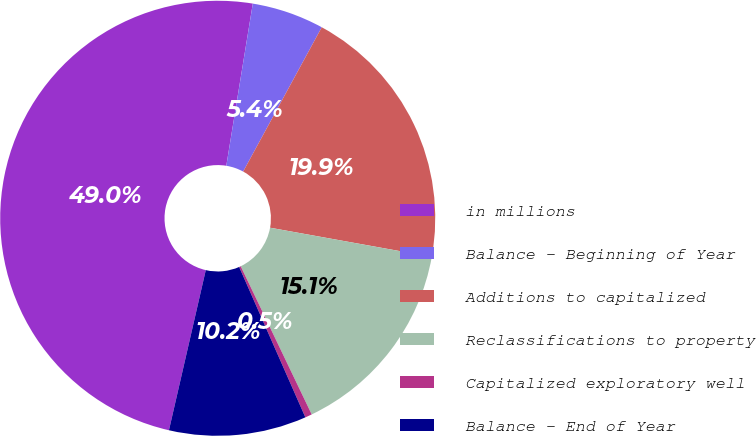Convert chart. <chart><loc_0><loc_0><loc_500><loc_500><pie_chart><fcel>in millions<fcel>Balance - Beginning of Year<fcel>Additions to capitalized<fcel>Reclassifications to property<fcel>Capitalized exploratory well<fcel>Balance - End of Year<nl><fcel>48.98%<fcel>5.36%<fcel>19.9%<fcel>15.05%<fcel>0.51%<fcel>10.2%<nl></chart> 